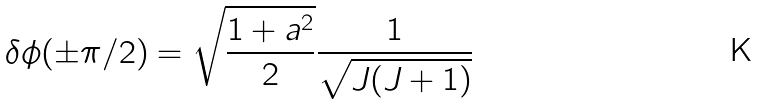<formula> <loc_0><loc_0><loc_500><loc_500>\delta \phi ( \pm \pi / 2 ) = \sqrt { \frac { 1 + a ^ { 2 } } { 2 } } \frac { 1 } { \sqrt { J ( J + 1 ) } }</formula> 